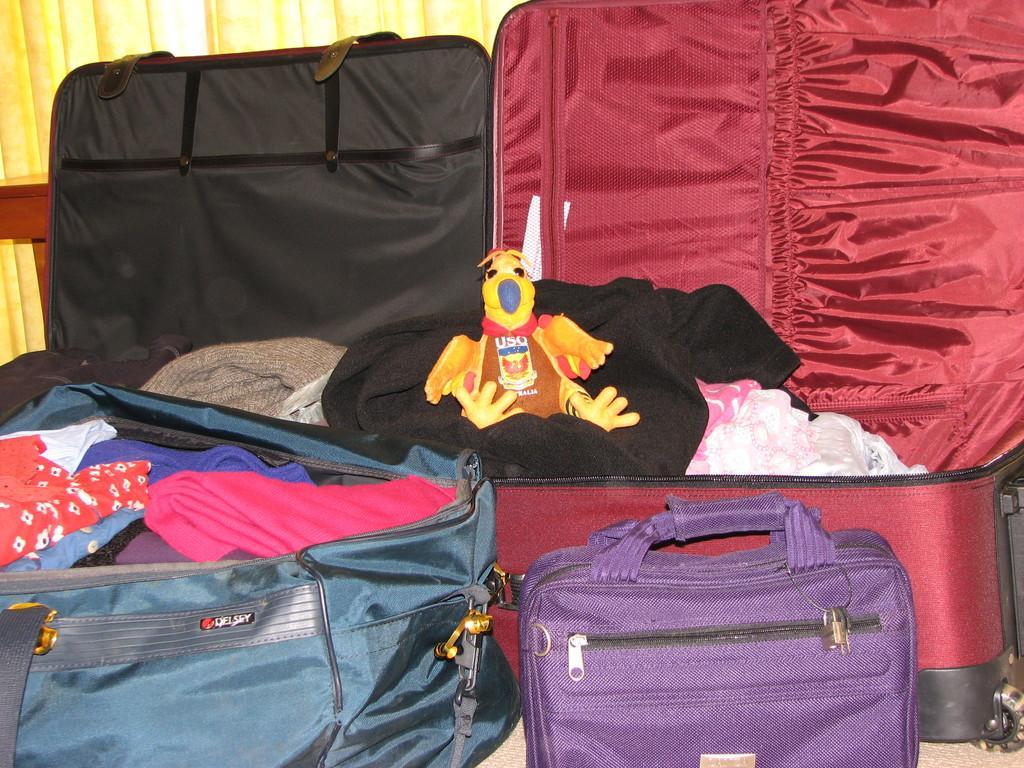In one or two sentences, can you explain what this image depicts? In this picture there are many bags filled with clothes and few of them are open , there is also a duck placed in the red bag. In the background we observe a yellow curtain. 